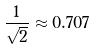Convert formula to latex. <formula><loc_0><loc_0><loc_500><loc_500>\frac { 1 } { \sqrt { 2 } } \approx 0 . 7 0 7</formula> 